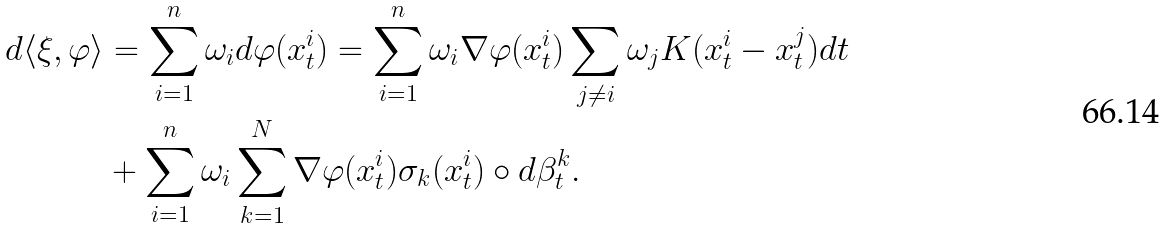Convert formula to latex. <formula><loc_0><loc_0><loc_500><loc_500>d \langle \xi , \varphi \rangle & = \sum _ { i = 1 } ^ { n } \omega _ { i } d \varphi ( x _ { t } ^ { i } ) = \sum _ { i = 1 } ^ { n } \omega _ { i } \nabla \varphi ( x _ { t } ^ { i } ) \sum _ { j \neq i } \omega _ { j } K ( x _ { t } ^ { i } - x _ { t } ^ { j } ) d t \\ & + \sum _ { i = 1 } ^ { n } \omega _ { i } \sum _ { k = 1 } ^ { N } \nabla \varphi ( x _ { t } ^ { i } ) \sigma _ { k } ( x _ { t } ^ { i } ) \circ d \beta _ { t } ^ { k } .</formula> 